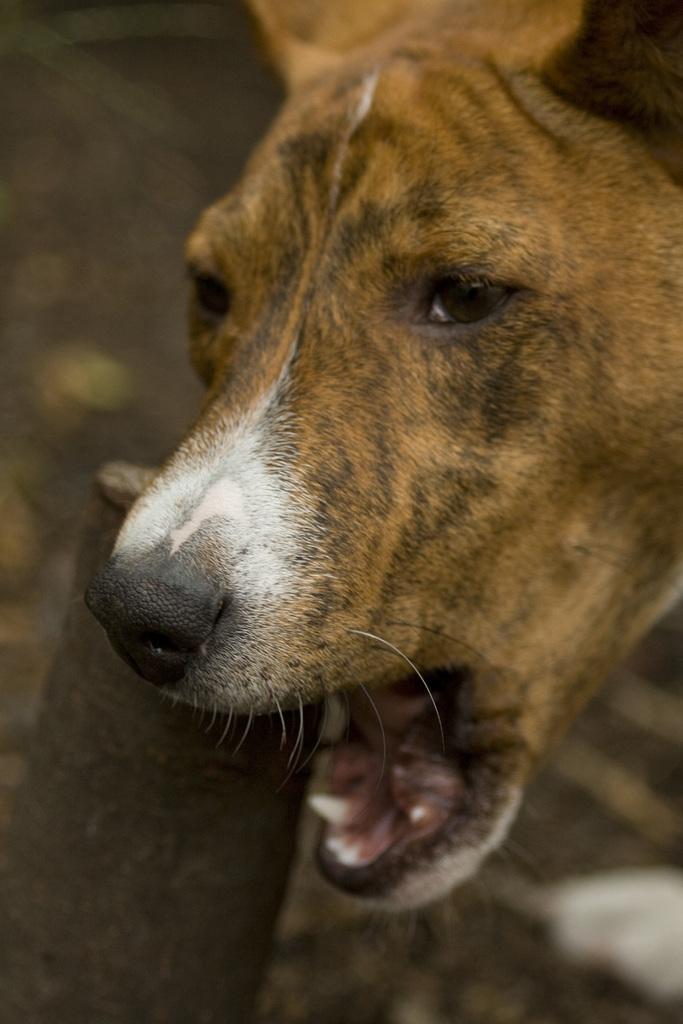In one or two sentences, can you explain what this image depicts? In this picture we can see a dog and in the background we can see the ground and it is blurry. 